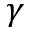<formula> <loc_0><loc_0><loc_500><loc_500>\gamma</formula> 